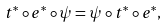<formula> <loc_0><loc_0><loc_500><loc_500>t ^ { * } \circ e ^ { * } \circ \psi = \psi \circ t ^ { * } \circ e ^ { * } ,</formula> 